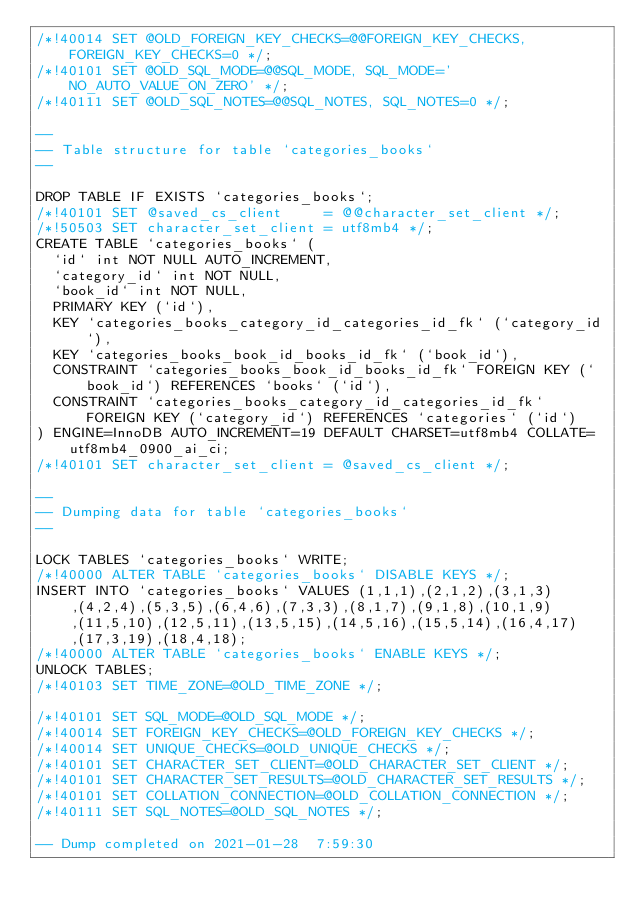<code> <loc_0><loc_0><loc_500><loc_500><_SQL_>/*!40014 SET @OLD_FOREIGN_KEY_CHECKS=@@FOREIGN_KEY_CHECKS, FOREIGN_KEY_CHECKS=0 */;
/*!40101 SET @OLD_SQL_MODE=@@SQL_MODE, SQL_MODE='NO_AUTO_VALUE_ON_ZERO' */;
/*!40111 SET @OLD_SQL_NOTES=@@SQL_NOTES, SQL_NOTES=0 */;

--
-- Table structure for table `categories_books`
--

DROP TABLE IF EXISTS `categories_books`;
/*!40101 SET @saved_cs_client     = @@character_set_client */;
/*!50503 SET character_set_client = utf8mb4 */;
CREATE TABLE `categories_books` (
  `id` int NOT NULL AUTO_INCREMENT,
  `category_id` int NOT NULL,
  `book_id` int NOT NULL,
  PRIMARY KEY (`id`),
  KEY `categories_books_category_id_categories_id_fk` (`category_id`),
  KEY `categories_books_book_id_books_id_fk` (`book_id`),
  CONSTRAINT `categories_books_book_id_books_id_fk` FOREIGN KEY (`book_id`) REFERENCES `books` (`id`),
  CONSTRAINT `categories_books_category_id_categories_id_fk` FOREIGN KEY (`category_id`) REFERENCES `categories` (`id`)
) ENGINE=InnoDB AUTO_INCREMENT=19 DEFAULT CHARSET=utf8mb4 COLLATE=utf8mb4_0900_ai_ci;
/*!40101 SET character_set_client = @saved_cs_client */;

--
-- Dumping data for table `categories_books`
--

LOCK TABLES `categories_books` WRITE;
/*!40000 ALTER TABLE `categories_books` DISABLE KEYS */;
INSERT INTO `categories_books` VALUES (1,1,1),(2,1,2),(3,1,3),(4,2,4),(5,3,5),(6,4,6),(7,3,3),(8,1,7),(9,1,8),(10,1,9),(11,5,10),(12,5,11),(13,5,15),(14,5,16),(15,5,14),(16,4,17),(17,3,19),(18,4,18);
/*!40000 ALTER TABLE `categories_books` ENABLE KEYS */;
UNLOCK TABLES;
/*!40103 SET TIME_ZONE=@OLD_TIME_ZONE */;

/*!40101 SET SQL_MODE=@OLD_SQL_MODE */;
/*!40014 SET FOREIGN_KEY_CHECKS=@OLD_FOREIGN_KEY_CHECKS */;
/*!40014 SET UNIQUE_CHECKS=@OLD_UNIQUE_CHECKS */;
/*!40101 SET CHARACTER_SET_CLIENT=@OLD_CHARACTER_SET_CLIENT */;
/*!40101 SET CHARACTER_SET_RESULTS=@OLD_CHARACTER_SET_RESULTS */;
/*!40101 SET COLLATION_CONNECTION=@OLD_COLLATION_CONNECTION */;
/*!40111 SET SQL_NOTES=@OLD_SQL_NOTES */;

-- Dump completed on 2021-01-28  7:59:30
</code> 